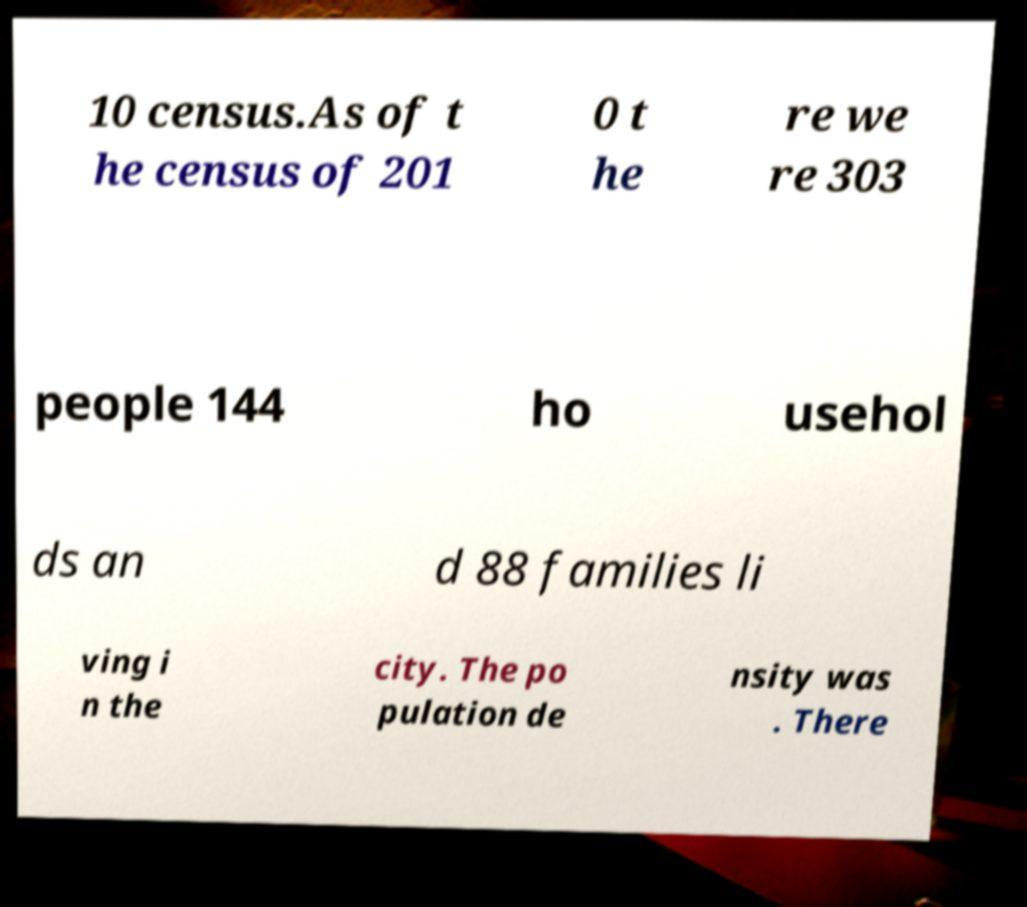There's text embedded in this image that I need extracted. Can you transcribe it verbatim? 10 census.As of t he census of 201 0 t he re we re 303 people 144 ho usehol ds an d 88 families li ving i n the city. The po pulation de nsity was . There 